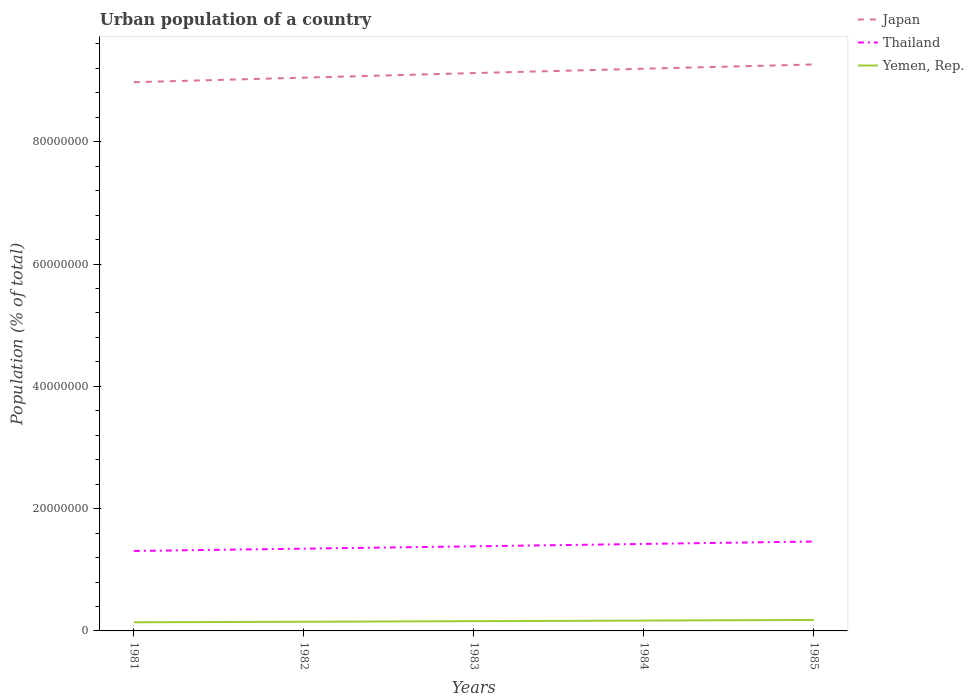How many different coloured lines are there?
Offer a terse response. 3. Does the line corresponding to Thailand intersect with the line corresponding to Japan?
Offer a very short reply. No. Is the number of lines equal to the number of legend labels?
Provide a short and direct response. Yes. Across all years, what is the maximum urban population in Japan?
Offer a very short reply. 8.97e+07. What is the total urban population in Thailand in the graph?
Offer a terse response. -7.60e+05. What is the difference between the highest and the second highest urban population in Yemen, Rep.?
Give a very brief answer. 3.82e+05. What is the difference between the highest and the lowest urban population in Thailand?
Give a very brief answer. 2. How many lines are there?
Make the answer very short. 3. How many years are there in the graph?
Offer a terse response. 5. What is the difference between two consecutive major ticks on the Y-axis?
Make the answer very short. 2.00e+07. Does the graph contain any zero values?
Your answer should be very brief. No. What is the title of the graph?
Your answer should be very brief. Urban population of a country. What is the label or title of the Y-axis?
Your response must be concise. Population (% of total). What is the Population (% of total) of Japan in 1981?
Your response must be concise. 8.97e+07. What is the Population (% of total) of Thailand in 1981?
Provide a short and direct response. 1.31e+07. What is the Population (% of total) in Yemen, Rep. in 1981?
Make the answer very short. 1.41e+06. What is the Population (% of total) in Japan in 1982?
Your response must be concise. 9.05e+07. What is the Population (% of total) in Thailand in 1982?
Your answer should be very brief. 1.35e+07. What is the Population (% of total) of Yemen, Rep. in 1982?
Make the answer very short. 1.50e+06. What is the Population (% of total) of Japan in 1983?
Make the answer very short. 9.12e+07. What is the Population (% of total) in Thailand in 1983?
Offer a very short reply. 1.38e+07. What is the Population (% of total) of Yemen, Rep. in 1983?
Your answer should be very brief. 1.59e+06. What is the Population (% of total) of Japan in 1984?
Keep it short and to the point. 9.19e+07. What is the Population (% of total) of Thailand in 1984?
Your response must be concise. 1.42e+07. What is the Population (% of total) in Yemen, Rep. in 1984?
Offer a very short reply. 1.69e+06. What is the Population (% of total) of Japan in 1985?
Ensure brevity in your answer.  9.26e+07. What is the Population (% of total) of Thailand in 1985?
Provide a succinct answer. 1.46e+07. What is the Population (% of total) in Yemen, Rep. in 1985?
Provide a short and direct response. 1.80e+06. Across all years, what is the maximum Population (% of total) in Japan?
Give a very brief answer. 9.26e+07. Across all years, what is the maximum Population (% of total) of Thailand?
Your answer should be very brief. 1.46e+07. Across all years, what is the maximum Population (% of total) in Yemen, Rep.?
Provide a short and direct response. 1.80e+06. Across all years, what is the minimum Population (% of total) in Japan?
Offer a very short reply. 8.97e+07. Across all years, what is the minimum Population (% of total) in Thailand?
Your response must be concise. 1.31e+07. Across all years, what is the minimum Population (% of total) of Yemen, Rep.?
Your answer should be compact. 1.41e+06. What is the total Population (% of total) of Japan in the graph?
Your response must be concise. 4.56e+08. What is the total Population (% of total) of Thailand in the graph?
Your answer should be compact. 6.92e+07. What is the total Population (% of total) of Yemen, Rep. in the graph?
Ensure brevity in your answer.  7.99e+06. What is the difference between the Population (% of total) in Japan in 1981 and that in 1982?
Offer a terse response. -7.41e+05. What is the difference between the Population (% of total) of Thailand in 1981 and that in 1982?
Offer a very short reply. -3.79e+05. What is the difference between the Population (% of total) in Yemen, Rep. in 1981 and that in 1982?
Provide a succinct answer. -8.70e+04. What is the difference between the Population (% of total) of Japan in 1981 and that in 1983?
Keep it short and to the point. -1.49e+06. What is the difference between the Population (% of total) of Thailand in 1981 and that in 1983?
Offer a very short reply. -7.60e+05. What is the difference between the Population (% of total) in Yemen, Rep. in 1981 and that in 1983?
Your answer should be compact. -1.80e+05. What is the difference between the Population (% of total) of Japan in 1981 and that in 1984?
Give a very brief answer. -2.20e+06. What is the difference between the Population (% of total) in Thailand in 1981 and that in 1984?
Make the answer very short. -1.15e+06. What is the difference between the Population (% of total) in Yemen, Rep. in 1981 and that in 1984?
Offer a terse response. -2.78e+05. What is the difference between the Population (% of total) of Japan in 1981 and that in 1985?
Provide a short and direct response. -2.90e+06. What is the difference between the Population (% of total) in Thailand in 1981 and that in 1985?
Make the answer very short. -1.55e+06. What is the difference between the Population (% of total) of Yemen, Rep. in 1981 and that in 1985?
Provide a succinct answer. -3.82e+05. What is the difference between the Population (% of total) of Japan in 1982 and that in 1983?
Offer a very short reply. -7.50e+05. What is the difference between the Population (% of total) of Thailand in 1982 and that in 1983?
Ensure brevity in your answer.  -3.82e+05. What is the difference between the Population (% of total) in Yemen, Rep. in 1982 and that in 1983?
Ensure brevity in your answer.  -9.28e+04. What is the difference between the Population (% of total) of Japan in 1982 and that in 1984?
Offer a terse response. -1.46e+06. What is the difference between the Population (% of total) in Thailand in 1982 and that in 1984?
Provide a short and direct response. -7.70e+05. What is the difference between the Population (% of total) of Yemen, Rep. in 1982 and that in 1984?
Your response must be concise. -1.91e+05. What is the difference between the Population (% of total) in Japan in 1982 and that in 1985?
Your answer should be very brief. -2.16e+06. What is the difference between the Population (% of total) of Thailand in 1982 and that in 1985?
Offer a terse response. -1.17e+06. What is the difference between the Population (% of total) in Yemen, Rep. in 1982 and that in 1985?
Your response must be concise. -2.95e+05. What is the difference between the Population (% of total) of Japan in 1983 and that in 1984?
Offer a terse response. -7.13e+05. What is the difference between the Population (% of total) in Thailand in 1983 and that in 1984?
Offer a terse response. -3.89e+05. What is the difference between the Population (% of total) in Yemen, Rep. in 1983 and that in 1984?
Offer a very short reply. -9.84e+04. What is the difference between the Population (% of total) in Japan in 1983 and that in 1985?
Your answer should be very brief. -1.41e+06. What is the difference between the Population (% of total) in Thailand in 1983 and that in 1985?
Ensure brevity in your answer.  -7.86e+05. What is the difference between the Population (% of total) of Yemen, Rep. in 1983 and that in 1985?
Provide a succinct answer. -2.02e+05. What is the difference between the Population (% of total) in Japan in 1984 and that in 1985?
Keep it short and to the point. -6.95e+05. What is the difference between the Population (% of total) in Thailand in 1984 and that in 1985?
Ensure brevity in your answer.  -3.97e+05. What is the difference between the Population (% of total) in Yemen, Rep. in 1984 and that in 1985?
Provide a succinct answer. -1.04e+05. What is the difference between the Population (% of total) in Japan in 1981 and the Population (% of total) in Thailand in 1982?
Your answer should be very brief. 7.63e+07. What is the difference between the Population (% of total) of Japan in 1981 and the Population (% of total) of Yemen, Rep. in 1982?
Offer a terse response. 8.82e+07. What is the difference between the Population (% of total) in Thailand in 1981 and the Population (% of total) in Yemen, Rep. in 1982?
Provide a succinct answer. 1.16e+07. What is the difference between the Population (% of total) in Japan in 1981 and the Population (% of total) in Thailand in 1983?
Your answer should be compact. 7.59e+07. What is the difference between the Population (% of total) of Japan in 1981 and the Population (% of total) of Yemen, Rep. in 1983?
Your answer should be very brief. 8.81e+07. What is the difference between the Population (% of total) in Thailand in 1981 and the Population (% of total) in Yemen, Rep. in 1983?
Make the answer very short. 1.15e+07. What is the difference between the Population (% of total) in Japan in 1981 and the Population (% of total) in Thailand in 1984?
Provide a succinct answer. 7.55e+07. What is the difference between the Population (% of total) in Japan in 1981 and the Population (% of total) in Yemen, Rep. in 1984?
Offer a terse response. 8.80e+07. What is the difference between the Population (% of total) of Thailand in 1981 and the Population (% of total) of Yemen, Rep. in 1984?
Your response must be concise. 1.14e+07. What is the difference between the Population (% of total) of Japan in 1981 and the Population (% of total) of Thailand in 1985?
Ensure brevity in your answer.  7.51e+07. What is the difference between the Population (% of total) in Japan in 1981 and the Population (% of total) in Yemen, Rep. in 1985?
Make the answer very short. 8.79e+07. What is the difference between the Population (% of total) in Thailand in 1981 and the Population (% of total) in Yemen, Rep. in 1985?
Give a very brief answer. 1.13e+07. What is the difference between the Population (% of total) of Japan in 1982 and the Population (% of total) of Thailand in 1983?
Give a very brief answer. 7.66e+07. What is the difference between the Population (% of total) of Japan in 1982 and the Population (% of total) of Yemen, Rep. in 1983?
Your answer should be very brief. 8.89e+07. What is the difference between the Population (% of total) in Thailand in 1982 and the Population (% of total) in Yemen, Rep. in 1983?
Offer a terse response. 1.19e+07. What is the difference between the Population (% of total) of Japan in 1982 and the Population (% of total) of Thailand in 1984?
Offer a very short reply. 7.63e+07. What is the difference between the Population (% of total) in Japan in 1982 and the Population (% of total) in Yemen, Rep. in 1984?
Your answer should be very brief. 8.88e+07. What is the difference between the Population (% of total) in Thailand in 1982 and the Population (% of total) in Yemen, Rep. in 1984?
Provide a short and direct response. 1.18e+07. What is the difference between the Population (% of total) in Japan in 1982 and the Population (% of total) in Thailand in 1985?
Give a very brief answer. 7.59e+07. What is the difference between the Population (% of total) of Japan in 1982 and the Population (% of total) of Yemen, Rep. in 1985?
Your response must be concise. 8.87e+07. What is the difference between the Population (% of total) of Thailand in 1982 and the Population (% of total) of Yemen, Rep. in 1985?
Provide a short and direct response. 1.17e+07. What is the difference between the Population (% of total) of Japan in 1983 and the Population (% of total) of Thailand in 1984?
Your answer should be very brief. 7.70e+07. What is the difference between the Population (% of total) in Japan in 1983 and the Population (% of total) in Yemen, Rep. in 1984?
Make the answer very short. 8.95e+07. What is the difference between the Population (% of total) in Thailand in 1983 and the Population (% of total) in Yemen, Rep. in 1984?
Provide a succinct answer. 1.21e+07. What is the difference between the Population (% of total) in Japan in 1983 and the Population (% of total) in Thailand in 1985?
Make the answer very short. 7.66e+07. What is the difference between the Population (% of total) of Japan in 1983 and the Population (% of total) of Yemen, Rep. in 1985?
Your response must be concise. 8.94e+07. What is the difference between the Population (% of total) of Thailand in 1983 and the Population (% of total) of Yemen, Rep. in 1985?
Provide a succinct answer. 1.20e+07. What is the difference between the Population (% of total) in Japan in 1984 and the Population (% of total) in Thailand in 1985?
Offer a terse response. 7.73e+07. What is the difference between the Population (% of total) of Japan in 1984 and the Population (% of total) of Yemen, Rep. in 1985?
Your answer should be very brief. 9.01e+07. What is the difference between the Population (% of total) of Thailand in 1984 and the Population (% of total) of Yemen, Rep. in 1985?
Offer a very short reply. 1.24e+07. What is the average Population (% of total) of Japan per year?
Provide a succinct answer. 9.12e+07. What is the average Population (% of total) of Thailand per year?
Your answer should be very brief. 1.38e+07. What is the average Population (% of total) of Yemen, Rep. per year?
Offer a very short reply. 1.60e+06. In the year 1981, what is the difference between the Population (% of total) in Japan and Population (% of total) in Thailand?
Your response must be concise. 7.67e+07. In the year 1981, what is the difference between the Population (% of total) in Japan and Population (% of total) in Yemen, Rep.?
Offer a terse response. 8.83e+07. In the year 1981, what is the difference between the Population (% of total) of Thailand and Population (% of total) of Yemen, Rep.?
Ensure brevity in your answer.  1.17e+07. In the year 1982, what is the difference between the Population (% of total) of Japan and Population (% of total) of Thailand?
Offer a terse response. 7.70e+07. In the year 1982, what is the difference between the Population (% of total) in Japan and Population (% of total) in Yemen, Rep.?
Your answer should be very brief. 8.90e+07. In the year 1982, what is the difference between the Population (% of total) in Thailand and Population (% of total) in Yemen, Rep.?
Ensure brevity in your answer.  1.20e+07. In the year 1983, what is the difference between the Population (% of total) of Japan and Population (% of total) of Thailand?
Offer a terse response. 7.74e+07. In the year 1983, what is the difference between the Population (% of total) of Japan and Population (% of total) of Yemen, Rep.?
Your answer should be very brief. 8.96e+07. In the year 1983, what is the difference between the Population (% of total) in Thailand and Population (% of total) in Yemen, Rep.?
Keep it short and to the point. 1.22e+07. In the year 1984, what is the difference between the Population (% of total) in Japan and Population (% of total) in Thailand?
Keep it short and to the point. 7.77e+07. In the year 1984, what is the difference between the Population (% of total) of Japan and Population (% of total) of Yemen, Rep.?
Keep it short and to the point. 9.02e+07. In the year 1984, what is the difference between the Population (% of total) in Thailand and Population (% of total) in Yemen, Rep.?
Provide a short and direct response. 1.25e+07. In the year 1985, what is the difference between the Population (% of total) in Japan and Population (% of total) in Thailand?
Make the answer very short. 7.80e+07. In the year 1985, what is the difference between the Population (% of total) of Japan and Population (% of total) of Yemen, Rep.?
Keep it short and to the point. 9.08e+07. In the year 1985, what is the difference between the Population (% of total) in Thailand and Population (% of total) in Yemen, Rep.?
Offer a very short reply. 1.28e+07. What is the ratio of the Population (% of total) of Japan in 1981 to that in 1982?
Your answer should be compact. 0.99. What is the ratio of the Population (% of total) of Thailand in 1981 to that in 1982?
Keep it short and to the point. 0.97. What is the ratio of the Population (% of total) in Yemen, Rep. in 1981 to that in 1982?
Give a very brief answer. 0.94. What is the ratio of the Population (% of total) in Japan in 1981 to that in 1983?
Your answer should be very brief. 0.98. What is the ratio of the Population (% of total) of Thailand in 1981 to that in 1983?
Your answer should be compact. 0.94. What is the ratio of the Population (% of total) of Yemen, Rep. in 1981 to that in 1983?
Provide a succinct answer. 0.89. What is the ratio of the Population (% of total) in Japan in 1981 to that in 1984?
Your answer should be compact. 0.98. What is the ratio of the Population (% of total) of Thailand in 1981 to that in 1984?
Offer a terse response. 0.92. What is the ratio of the Population (% of total) in Yemen, Rep. in 1981 to that in 1984?
Offer a terse response. 0.84. What is the ratio of the Population (% of total) of Japan in 1981 to that in 1985?
Provide a short and direct response. 0.97. What is the ratio of the Population (% of total) in Thailand in 1981 to that in 1985?
Your response must be concise. 0.89. What is the ratio of the Population (% of total) of Yemen, Rep. in 1981 to that in 1985?
Provide a succinct answer. 0.79. What is the ratio of the Population (% of total) of Japan in 1982 to that in 1983?
Your answer should be very brief. 0.99. What is the ratio of the Population (% of total) in Thailand in 1982 to that in 1983?
Ensure brevity in your answer.  0.97. What is the ratio of the Population (% of total) of Yemen, Rep. in 1982 to that in 1983?
Make the answer very short. 0.94. What is the ratio of the Population (% of total) of Japan in 1982 to that in 1984?
Your answer should be very brief. 0.98. What is the ratio of the Population (% of total) in Thailand in 1982 to that in 1984?
Make the answer very short. 0.95. What is the ratio of the Population (% of total) in Yemen, Rep. in 1982 to that in 1984?
Your response must be concise. 0.89. What is the ratio of the Population (% of total) in Japan in 1982 to that in 1985?
Offer a terse response. 0.98. What is the ratio of the Population (% of total) of Thailand in 1982 to that in 1985?
Your response must be concise. 0.92. What is the ratio of the Population (% of total) of Yemen, Rep. in 1982 to that in 1985?
Your answer should be compact. 0.84. What is the ratio of the Population (% of total) of Japan in 1983 to that in 1984?
Make the answer very short. 0.99. What is the ratio of the Population (% of total) in Thailand in 1983 to that in 1984?
Ensure brevity in your answer.  0.97. What is the ratio of the Population (% of total) in Yemen, Rep. in 1983 to that in 1984?
Make the answer very short. 0.94. What is the ratio of the Population (% of total) of Thailand in 1983 to that in 1985?
Keep it short and to the point. 0.95. What is the ratio of the Population (% of total) of Yemen, Rep. in 1983 to that in 1985?
Give a very brief answer. 0.89. What is the ratio of the Population (% of total) of Japan in 1984 to that in 1985?
Offer a very short reply. 0.99. What is the ratio of the Population (% of total) of Thailand in 1984 to that in 1985?
Provide a short and direct response. 0.97. What is the ratio of the Population (% of total) of Yemen, Rep. in 1984 to that in 1985?
Give a very brief answer. 0.94. What is the difference between the highest and the second highest Population (% of total) of Japan?
Give a very brief answer. 6.95e+05. What is the difference between the highest and the second highest Population (% of total) in Thailand?
Ensure brevity in your answer.  3.97e+05. What is the difference between the highest and the second highest Population (% of total) of Yemen, Rep.?
Your answer should be very brief. 1.04e+05. What is the difference between the highest and the lowest Population (% of total) of Japan?
Offer a terse response. 2.90e+06. What is the difference between the highest and the lowest Population (% of total) of Thailand?
Your answer should be compact. 1.55e+06. What is the difference between the highest and the lowest Population (% of total) of Yemen, Rep.?
Your response must be concise. 3.82e+05. 